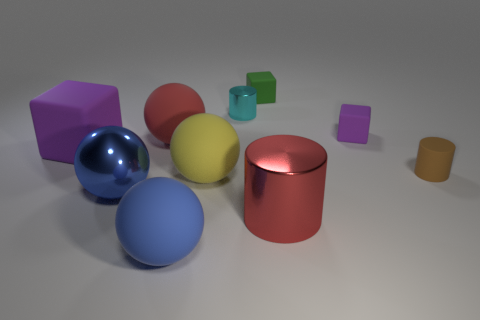The thing that is the same color as the metallic ball is what shape?
Give a very brief answer. Sphere. How many blue objects are the same size as the cyan metal object?
Provide a short and direct response. 0. Is the small brown thing on the right side of the tiny purple block made of the same material as the red sphere?
Your answer should be very brief. Yes. Are there any large red things?
Provide a succinct answer. Yes. The cylinder that is the same material as the yellow ball is what size?
Your response must be concise. Small. Are there any tiny matte things of the same color as the large metal cylinder?
Ensure brevity in your answer.  No. Is the color of the metal thing in front of the big blue metallic object the same as the large rubber ball on the right side of the big blue rubber sphere?
Offer a very short reply. No. What is the size of the matte sphere that is the same color as the big cylinder?
Your response must be concise. Large. Are there any red things made of the same material as the yellow ball?
Ensure brevity in your answer.  Yes. The large cylinder is what color?
Your response must be concise. Red. 